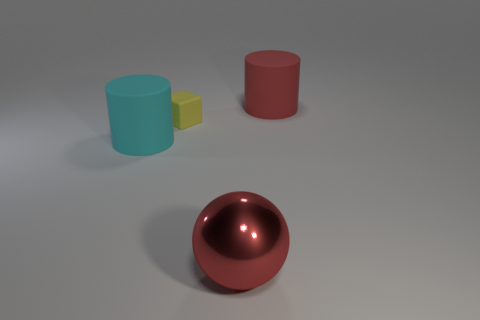Subtract all green balls. Subtract all green cylinders. How many balls are left? 1 Subtract all yellow balls. How many red cylinders are left? 1 Add 1 cyans. How many reds exist? 0 Subtract all red cylinders. Subtract all red rubber things. How many objects are left? 2 Add 2 spheres. How many spheres are left? 3 Add 3 tiny yellow things. How many tiny yellow things exist? 4 Add 3 yellow rubber cubes. How many objects exist? 7 Subtract all cyan cylinders. How many cylinders are left? 1 Subtract 1 yellow blocks. How many objects are left? 3 Subtract all spheres. How many objects are left? 3 